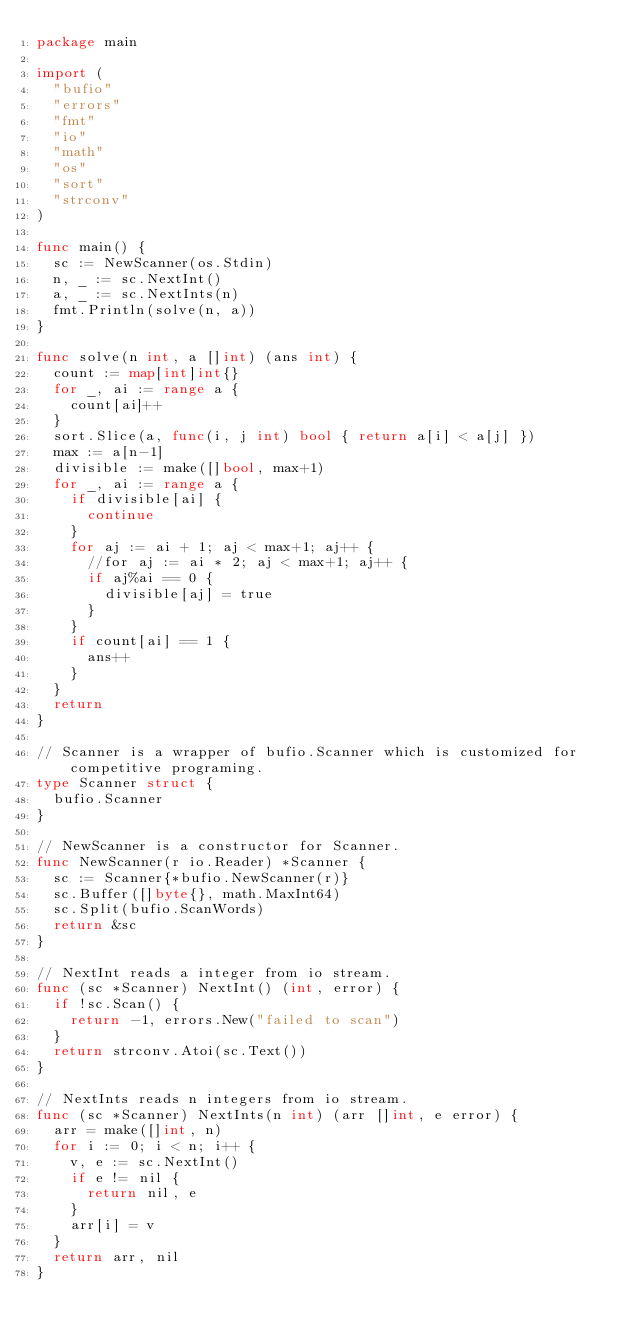Convert code to text. <code><loc_0><loc_0><loc_500><loc_500><_Go_>package main

import (
	"bufio"
	"errors"
	"fmt"
	"io"
	"math"
	"os"
	"sort"
	"strconv"
)

func main() {
	sc := NewScanner(os.Stdin)
	n, _ := sc.NextInt()
	a, _ := sc.NextInts(n)
	fmt.Println(solve(n, a))
}

func solve(n int, a []int) (ans int) {
	count := map[int]int{}
	for _, ai := range a {
		count[ai]++
	}
	sort.Slice(a, func(i, j int) bool { return a[i] < a[j] })
	max := a[n-1]
	divisible := make([]bool, max+1)
	for _, ai := range a {
		if divisible[ai] {
			continue
		}
		for aj := ai + 1; aj < max+1; aj++ {
			//for aj := ai * 2; aj < max+1; aj++ {
			if aj%ai == 0 {
				divisible[aj] = true
			}
		}
		if count[ai] == 1 {
			ans++
		}
	}
	return
}

// Scanner is a wrapper of bufio.Scanner which is customized for competitive programing.
type Scanner struct {
	bufio.Scanner
}

// NewScanner is a constructor for Scanner.
func NewScanner(r io.Reader) *Scanner {
	sc := Scanner{*bufio.NewScanner(r)}
	sc.Buffer([]byte{}, math.MaxInt64)
	sc.Split(bufio.ScanWords)
	return &sc
}

// NextInt reads a integer from io stream.
func (sc *Scanner) NextInt() (int, error) {
	if !sc.Scan() {
		return -1, errors.New("failed to scan")
	}
	return strconv.Atoi(sc.Text())
}

// NextInts reads n integers from io stream.
func (sc *Scanner) NextInts(n int) (arr []int, e error) {
	arr = make([]int, n)
	for i := 0; i < n; i++ {
		v, e := sc.NextInt()
		if e != nil {
			return nil, e
		}
		arr[i] = v
	}
	return arr, nil
}
</code> 